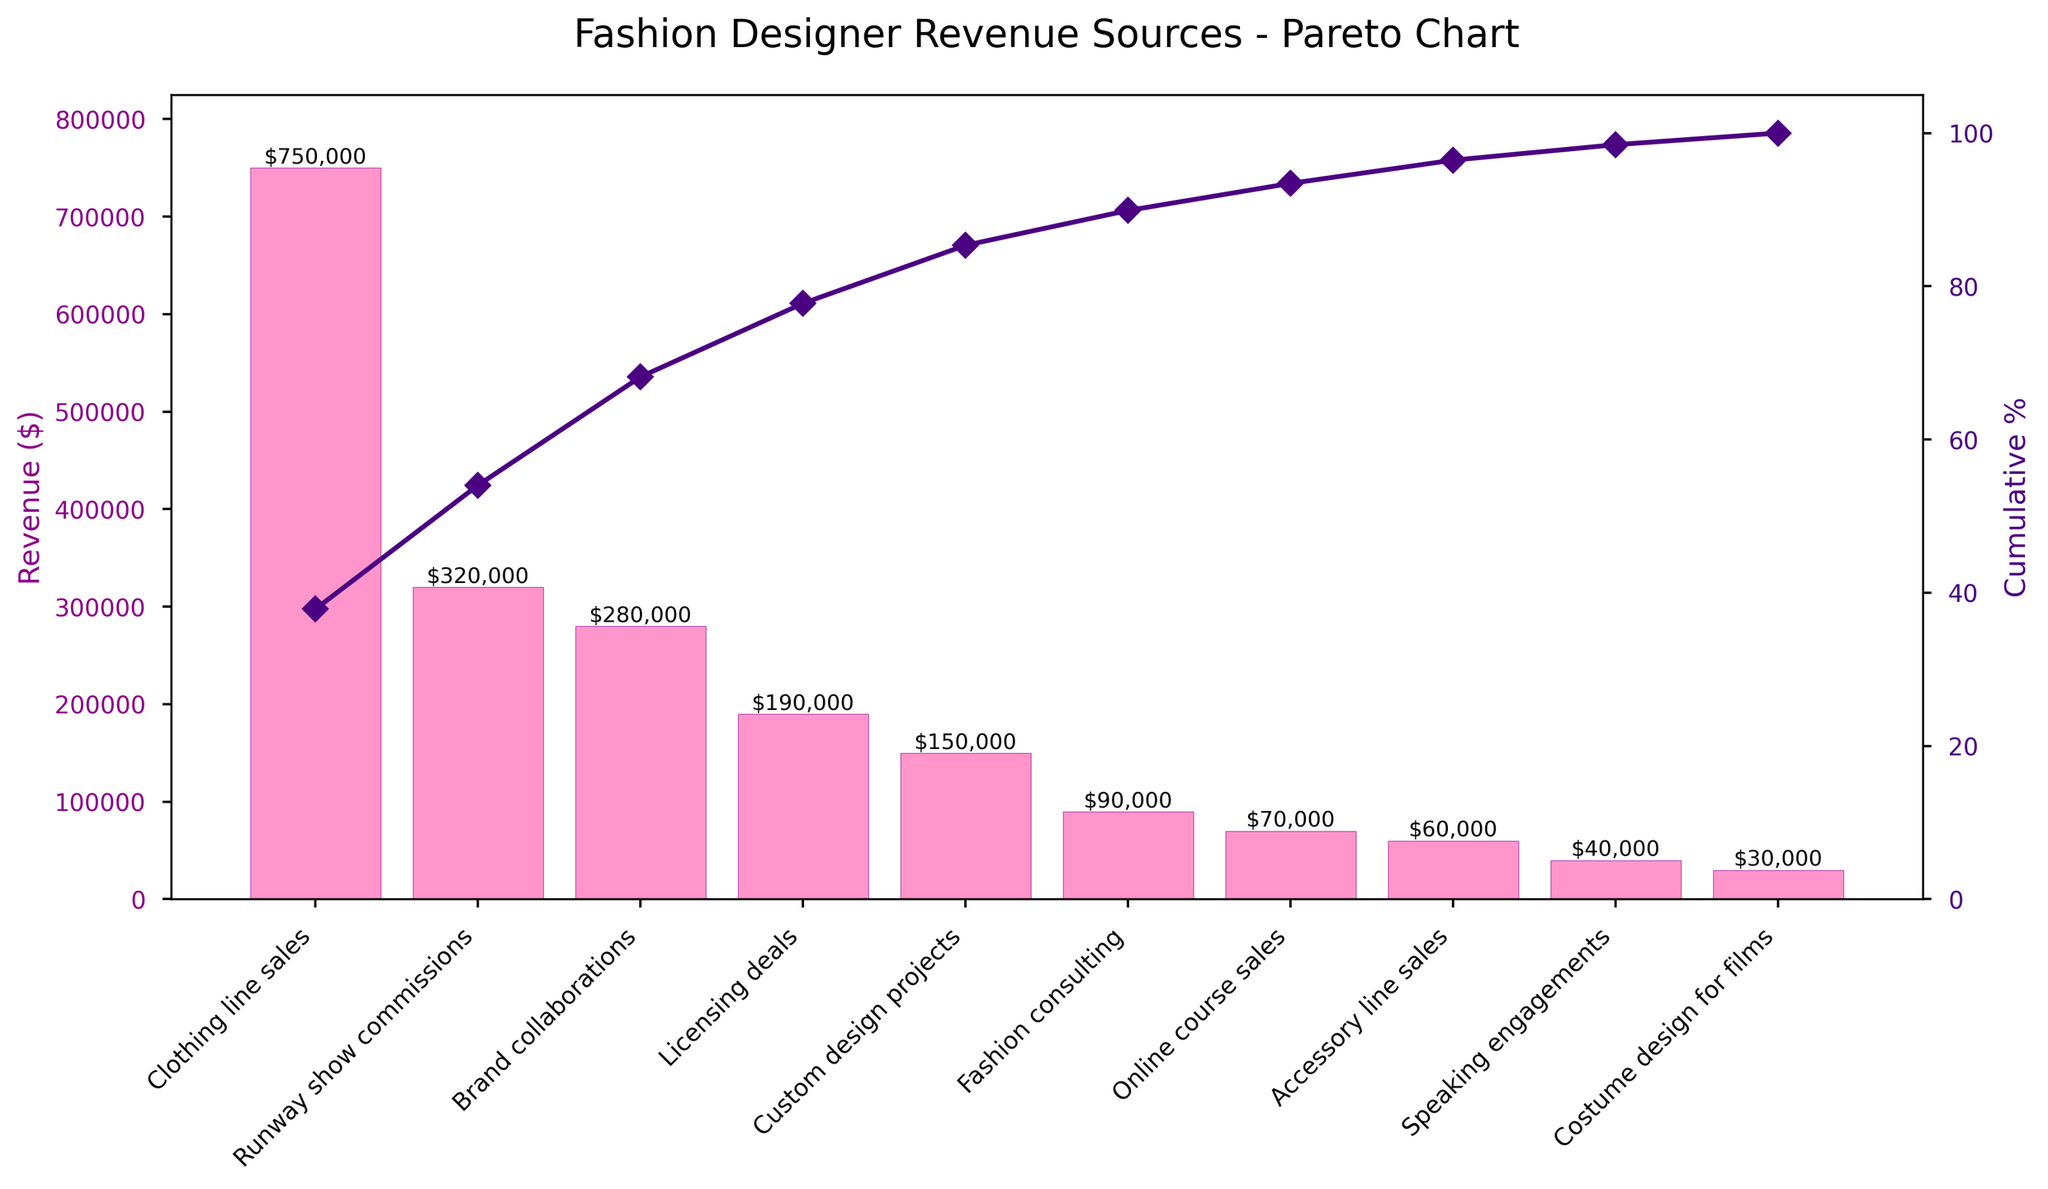How many revenue sources are displayed in the chart? By counting the bars on the bar chart representing each revenue source, you identify that there are 10 categories listed, each represented by a different bar.
Answer: 10 What is the total revenue generated from Runway show commissions and Brand collaborations? From the values on the bars, Runway show commissions = $320,000 and Brand collaborations = $280,000. Summing these values: $320,000 + $280,000 = $600,000.
Answer: $600,000 Which revenue source has the highest revenue? From examining the heights of the bars and the labels, 'Clothing line sales' has the highest revenue at $750,000.
Answer: Clothing line sales How much more revenue is generated from Licensing deals compared to Online course sales? From the values on the bars, Licensing deals = $190,000 and Online course sales = $70,000. The difference is $190,000 - $70,000 = $120,000.
Answer: $120,000 What is the cumulative percentage for the top three revenue sources? The top three revenue sources are 'Clothing line sales', 'Runway show commissions', and 'Brand collaborations'. Their cumulative revenues are $750,000 + $320,000 + $280,000 = $1,350,000. The total revenue from all categories is $1,980,000. The cumulative percentage is ($1,350,000 / $1,980,000) * 100 ≈ 68.18%.
Answer: ≈ 68.18% What percentage of total revenue does the 'Accessory line sales' contribute? From the bar chart, Accessory line sales revenue = $60,000. The total revenue from all categories is $1,980,000. The percentage contribution is ($60,000 / $1,980,000) * 100 ≈ 3.03%.
Answer: ≈ 3.03% Between Custom design projects and Fashion consulting, which generates less revenue, and by how much? From the bar chart, Custom design projects = $150,000 and Fashion consulting = $90,000. Fashion consulting generates less revenue. The difference is $150,000 - $90,000 = $60,000.
Answer: Fashion consulting by $60,000 What percentage of total revenue is accounted for by categories with revenues less than $100,000? Categories with revenues less than $100,000 are Fashion consulting ($90,000), Online course sales ($70,000), Accessory line sales ($60,000), Speaking engagements ($40,000), and Costume design for films ($30,000), summing to $290,000. The total revenue is $1,980,000. The percentage is ($290,000 / $1,980,000) * 100 ≈ 14.65%.
Answer: ≈ 14.65% At what point does the cumulative percentage curve reach approximately 50%? By examining the line plot for cumulative percentage, it crosses approximately 50% after the 'Runway show commissions' category, since adding its revenue to 'Clothing line sales' ($750,000 + $320,000 = $1,070,000) gives us a cumulative percentage of around 54.04%.
Answer: After 'Runway show commissions' What is the y-axis label for the bar chart and the line chart? The y-axis label for the bar chart is 'Revenue ($)', and for the line chart representing cumulative percentage, it is 'Cumulative %'.
Answer: Revenue ($) and Cumulative % 